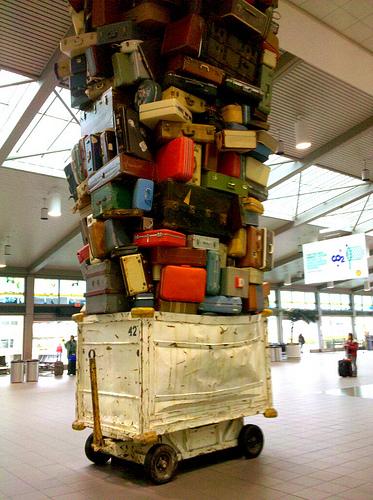How many tires can be seen?
Short answer required. 3. How many suitcases are there?
Keep it brief. 50. Is this an airport?
Concise answer only. Yes. 